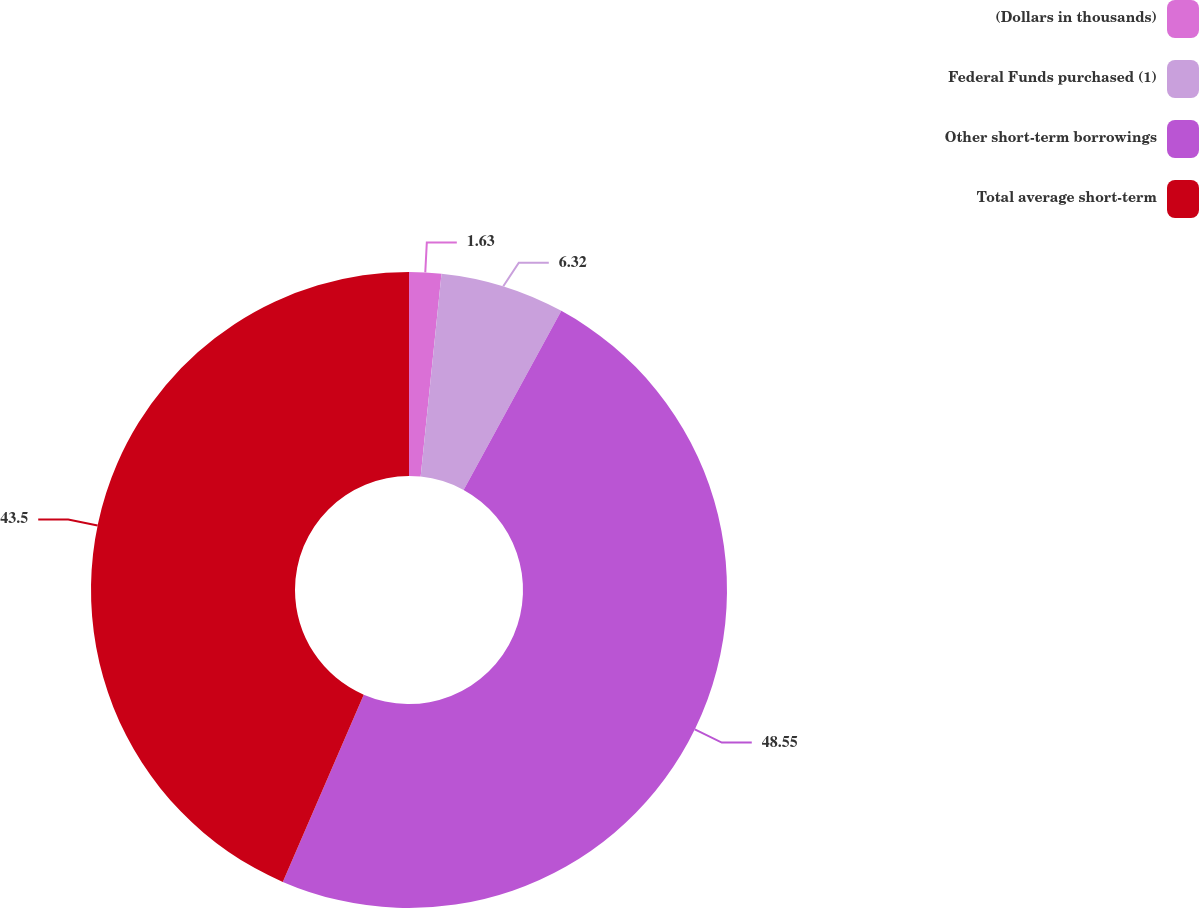<chart> <loc_0><loc_0><loc_500><loc_500><pie_chart><fcel>(Dollars in thousands)<fcel>Federal Funds purchased (1)<fcel>Other short-term borrowings<fcel>Total average short-term<nl><fcel>1.63%<fcel>6.32%<fcel>48.54%<fcel>43.5%<nl></chart> 